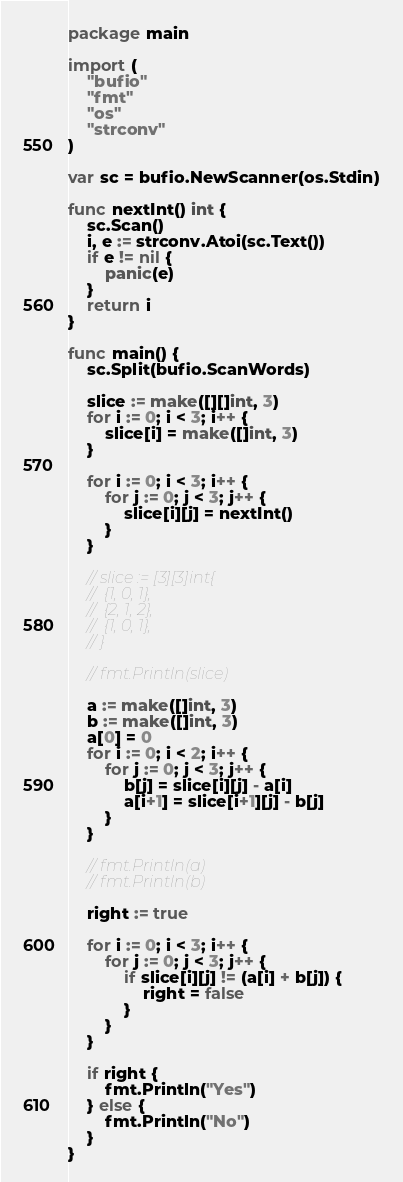<code> <loc_0><loc_0><loc_500><loc_500><_Go_>package main

import (
	"bufio"
	"fmt"
	"os"
	"strconv"
)

var sc = bufio.NewScanner(os.Stdin)

func nextInt() int {
	sc.Scan()
	i, e := strconv.Atoi(sc.Text())
	if e != nil {
		panic(e)
	}
	return i
}

func main() {
	sc.Split(bufio.ScanWords)

	slice := make([][]int, 3)
	for i := 0; i < 3; i++ {
		slice[i] = make([]int, 3)
	}

	for i := 0; i < 3; i++ {
		for j := 0; j < 3; j++ {
			slice[i][j] = nextInt()
		}
	}

	// slice := [3][3]int{
	// 	{1, 0, 1},
	// 	{2, 1, 2},
	// 	{1, 0, 1},
	// }

	// fmt.Println(slice)

	a := make([]int, 3)
	b := make([]int, 3)
	a[0] = 0
	for i := 0; i < 2; i++ {
		for j := 0; j < 3; j++ {
			b[j] = slice[i][j] - a[i]
			a[i+1] = slice[i+1][j] - b[j]
		}
	}

	// fmt.Println(a)
	// fmt.Println(b)

	right := true

	for i := 0; i < 3; i++ {
		for j := 0; j < 3; j++ {
			if slice[i][j] != (a[i] + b[j]) {
				right = false
			}
		}
	}

	if right {
		fmt.Println("Yes")
	} else {
		fmt.Println("No")
	}
}
</code> 